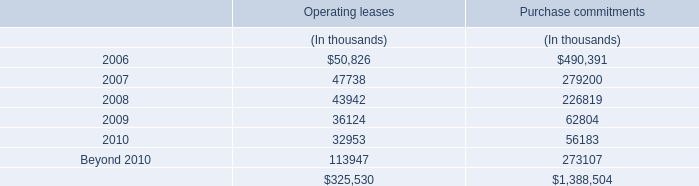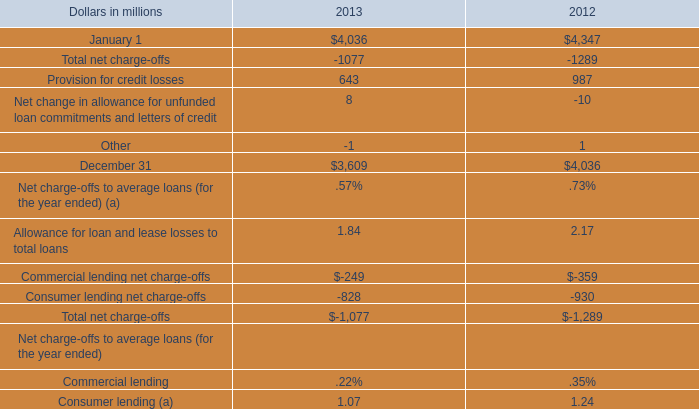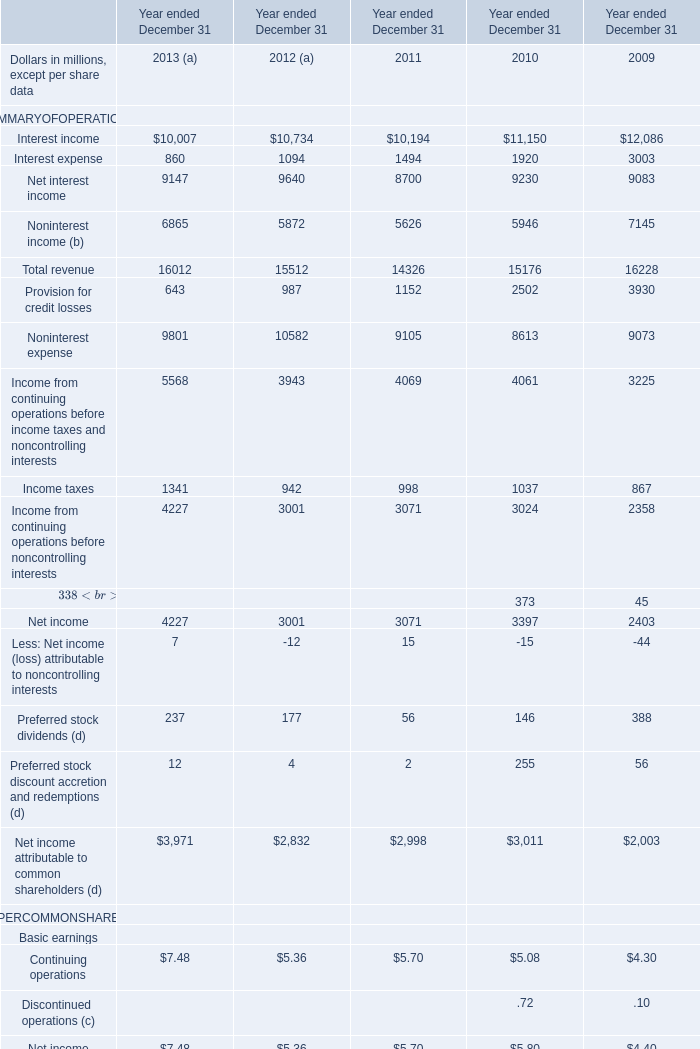What is the sum of the Interest income in the years where Interest income is positive? (in million) 
Computations: ((((10007 + 10734) + 10194) + 11150) + 12086)
Answer: 54171.0. 